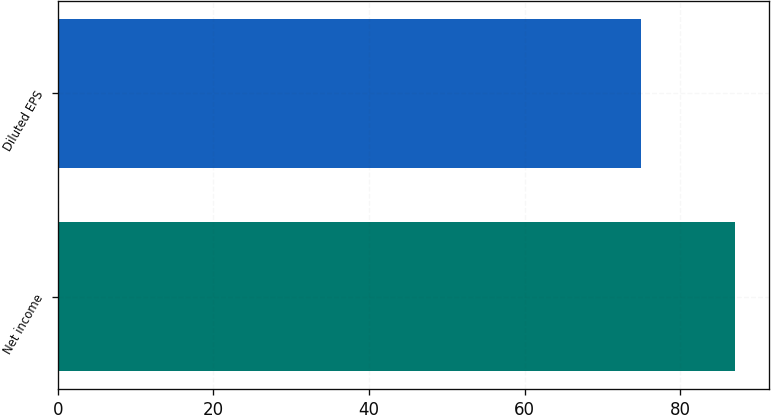<chart> <loc_0><loc_0><loc_500><loc_500><bar_chart><fcel>Net income<fcel>Diluted EPS<nl><fcel>87<fcel>75<nl></chart> 